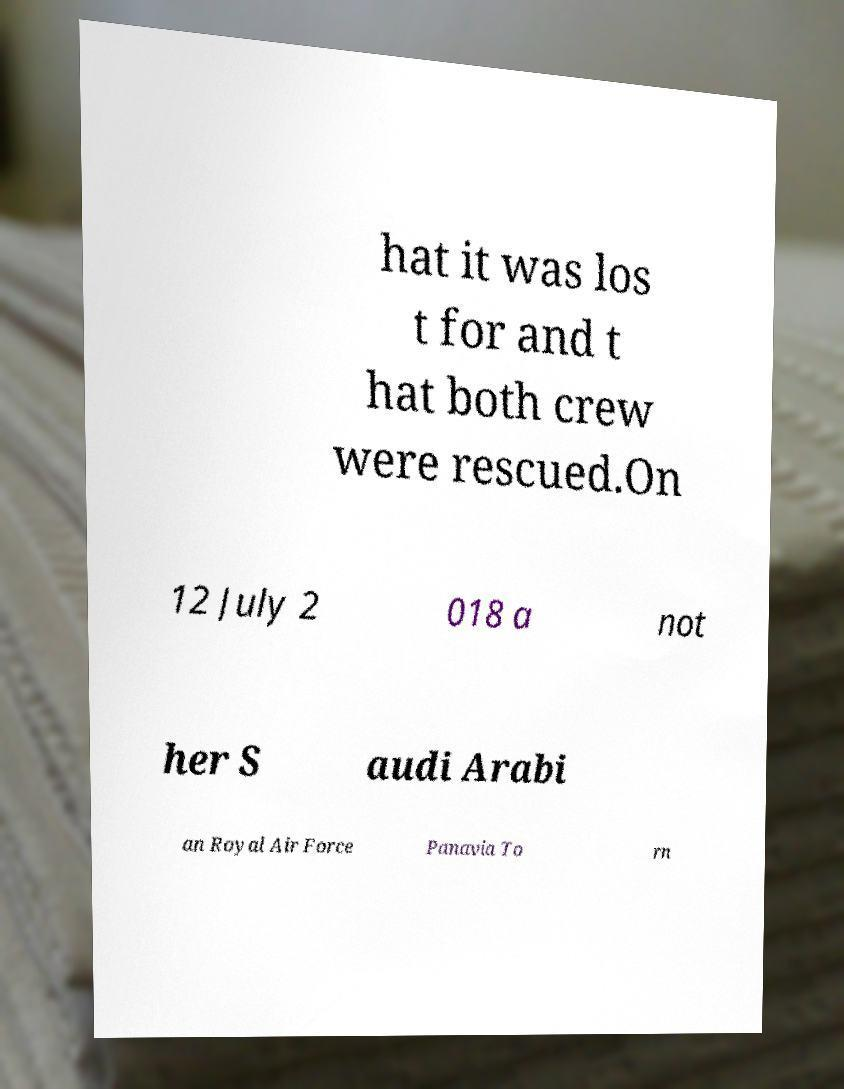Could you assist in decoding the text presented in this image and type it out clearly? hat it was los t for and t hat both crew were rescued.On 12 July 2 018 a not her S audi Arabi an Royal Air Force Panavia To rn 